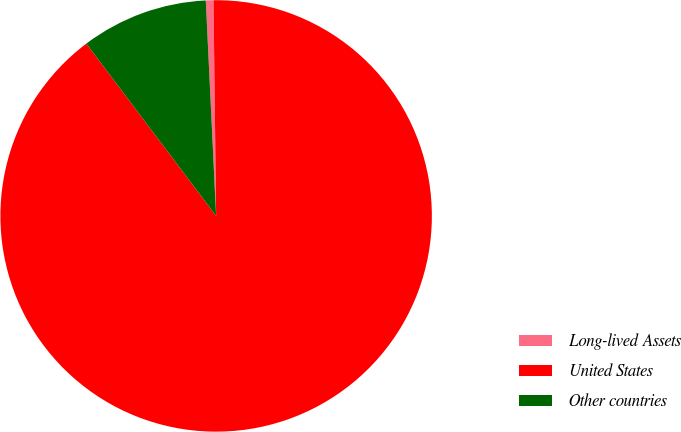<chart> <loc_0><loc_0><loc_500><loc_500><pie_chart><fcel>Long-lived Assets<fcel>United States<fcel>Other countries<nl><fcel>0.57%<fcel>89.92%<fcel>9.51%<nl></chart> 